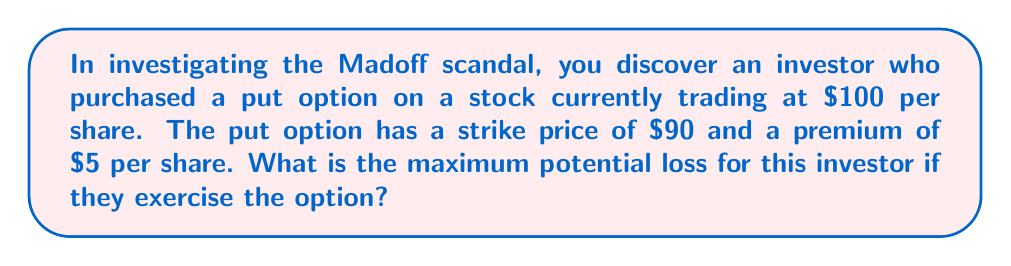Provide a solution to this math problem. To determine the maximum potential loss for the investor, we need to analyze the payoff structure of a put option:

1. The investor pays a premium of $5 per share upfront.

2. The put option gives the investor the right to sell the stock at the strike price of $90.

3. The maximum loss occurs when the stock price is at or above the strike price at expiration, as the option would expire worthless.

4. In this scenario, the investor loses only the premium paid.

5. The maximum loss can be calculated as:

   $$ \text{Maximum Loss} = \text{Premium Paid} $$

6. Given the premium is $5 per share:

   $$ \text{Maximum Loss} = $5 \text{ per share} $$

7. It's important to note that this loss is limited, which is one of the advantages of using options as a hedging strategy.

8. The loss is the same regardless of how high the stock price might go above the strike price.

This analysis demonstrates how derivatives like put options can be used to limit potential losses, which is crucial information when investigating financial strategies in the aftermath of scandals like Madoff's.
Answer: $5 per share 